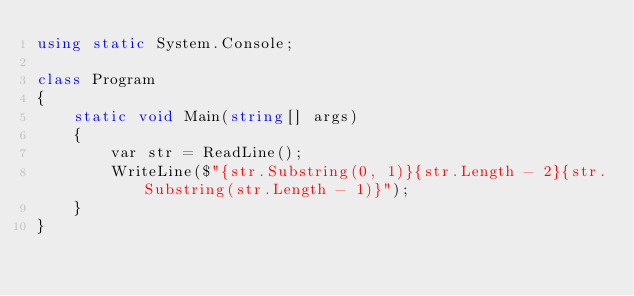Convert code to text. <code><loc_0><loc_0><loc_500><loc_500><_C#_>using static System.Console;

class Program
{
    static void Main(string[] args)
    {
        var str = ReadLine();
        WriteLine($"{str.Substring(0, 1)}{str.Length - 2}{str.Substring(str.Length - 1)}");
    }
}
</code> 